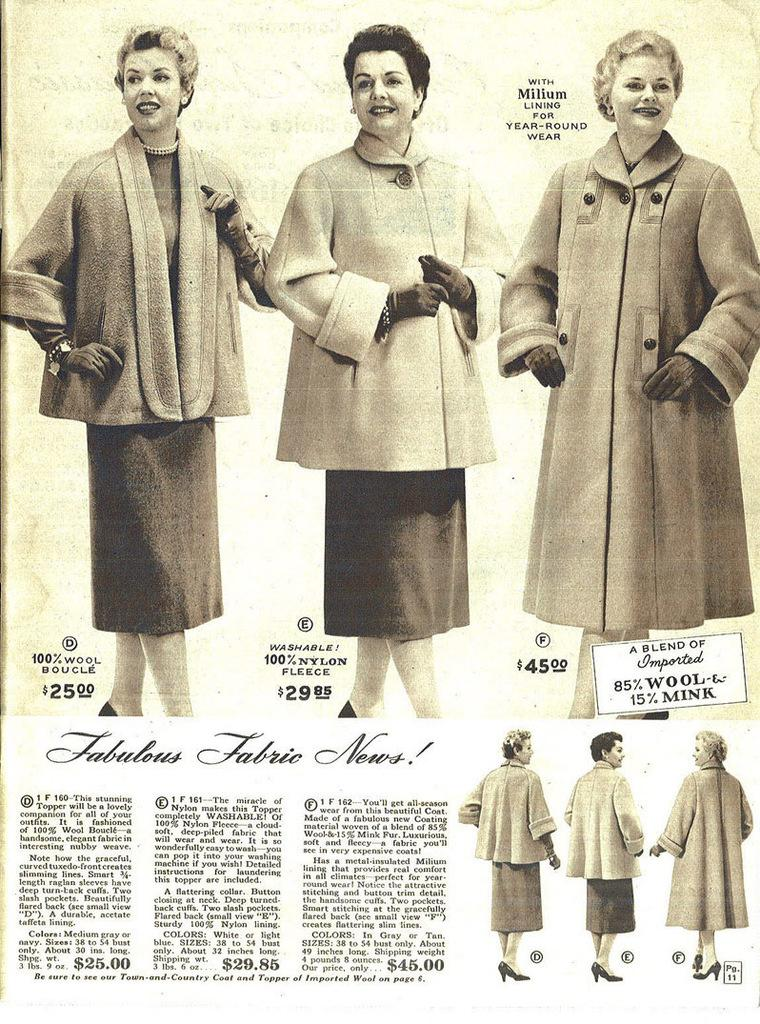What is present in the image that can be written or drawn on? There is a paper in the image. What type of images can be seen on the paper? There are pictures of women in the image. What substance is being learned by the group in the image? There is no group or learning activity present in the image; it only features a paper with pictures of women. 